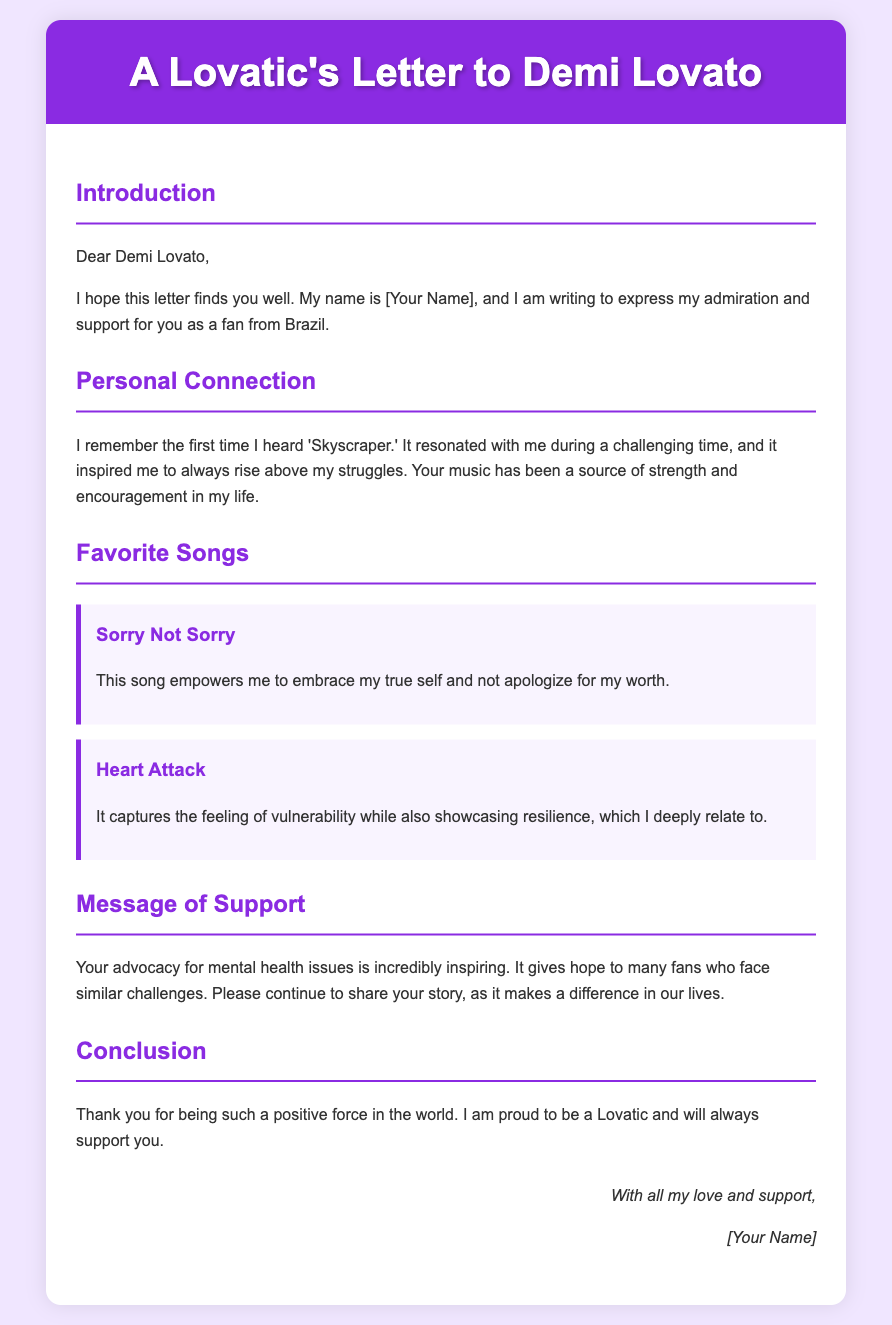What is the letter's title? The title appears in the header section of the document, stating the subject of the letter.
Answer: A Lovatic's Letter to Demi Lovato What song is mentioned as the first favorite? The document includes a section where specific songs are highlighted as favorites, starting with this one.
Answer: Sorry Not Sorry What color is the background of the letter? The background color can be observed in the overall styling of the document.
Answer: #f0e6ff Who is the letter addressed to? The salutation of the letter clearly indicates the recipient's name.
Answer: Demi Lovato What message does the author express regarding mental health? The document contains a section that specifically addresses the author's thoughts on this topic.
Answer: It gives hope to many fans who face similar challenges How does the author describe 'Skyscraper'? The author shares a personal connection with this song in a specific section.
Answer: It resonated with me during a challenging time 